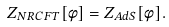<formula> <loc_0><loc_0><loc_500><loc_500>Z _ { N R C F T } [ \phi ] = Z _ { A d S } [ \phi ] .</formula> 